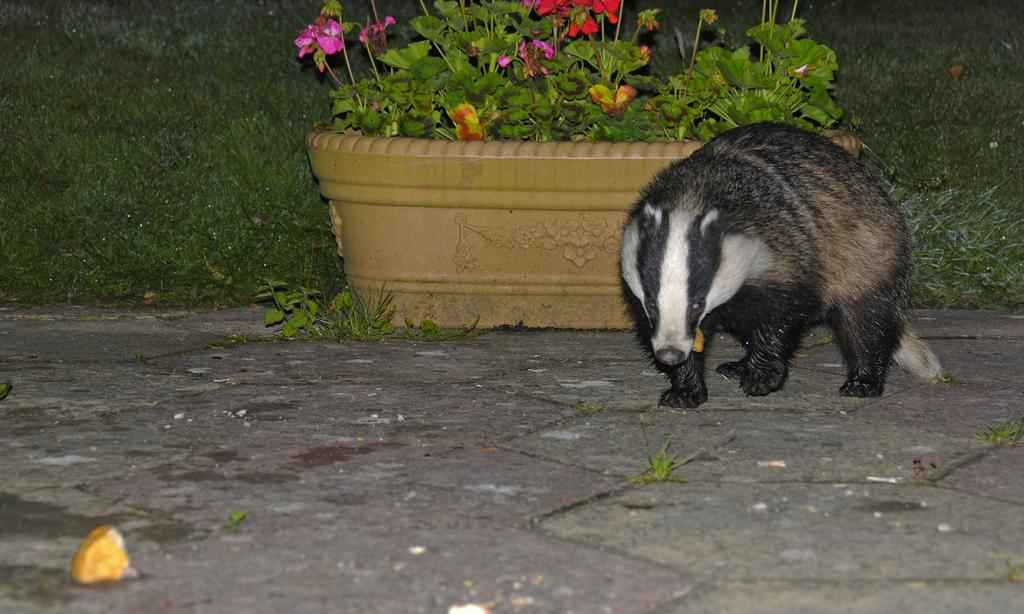What type of creature can be seen in the image? There is an animal in the image. What is the animal doing in the image? The animal is standing on the ground. What other object is present in the image besides the animal? There is a big flower pot in the image. What type of vegetation is visible in the image? There is grass in the image. What is the name of the kittens playing with the animal in the image? There are no kittens present in the image, and the animal's name is not mentioned. 